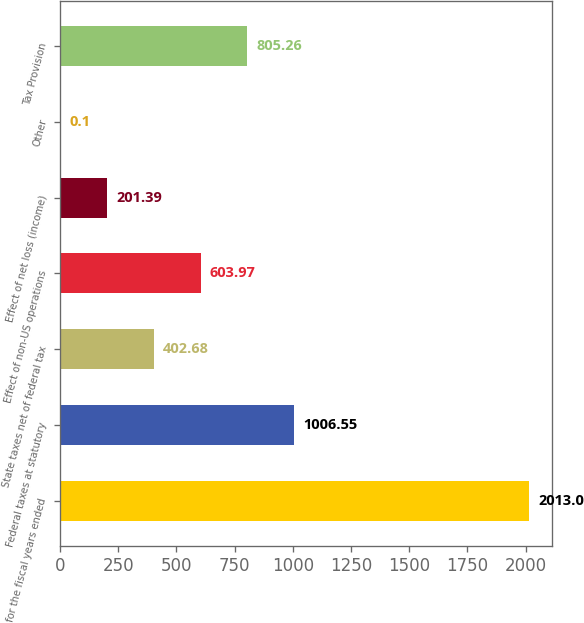<chart> <loc_0><loc_0><loc_500><loc_500><bar_chart><fcel>for the fiscal years ended<fcel>Federal taxes at statutory<fcel>State taxes net of federal tax<fcel>Effect of non-US operations<fcel>Effect of net loss (income)<fcel>Other<fcel>Tax Provision<nl><fcel>2013<fcel>1006.55<fcel>402.68<fcel>603.97<fcel>201.39<fcel>0.1<fcel>805.26<nl></chart> 